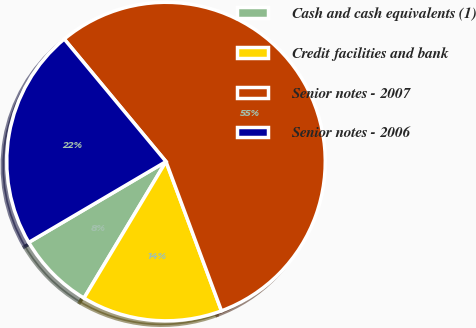Convert chart to OTSL. <chart><loc_0><loc_0><loc_500><loc_500><pie_chart><fcel>Cash and cash equivalents (1)<fcel>Credit facilities and bank<fcel>Senior notes - 2007<fcel>Senior notes - 2006<nl><fcel>7.92%<fcel>14.27%<fcel>55.37%<fcel>22.44%<nl></chart> 